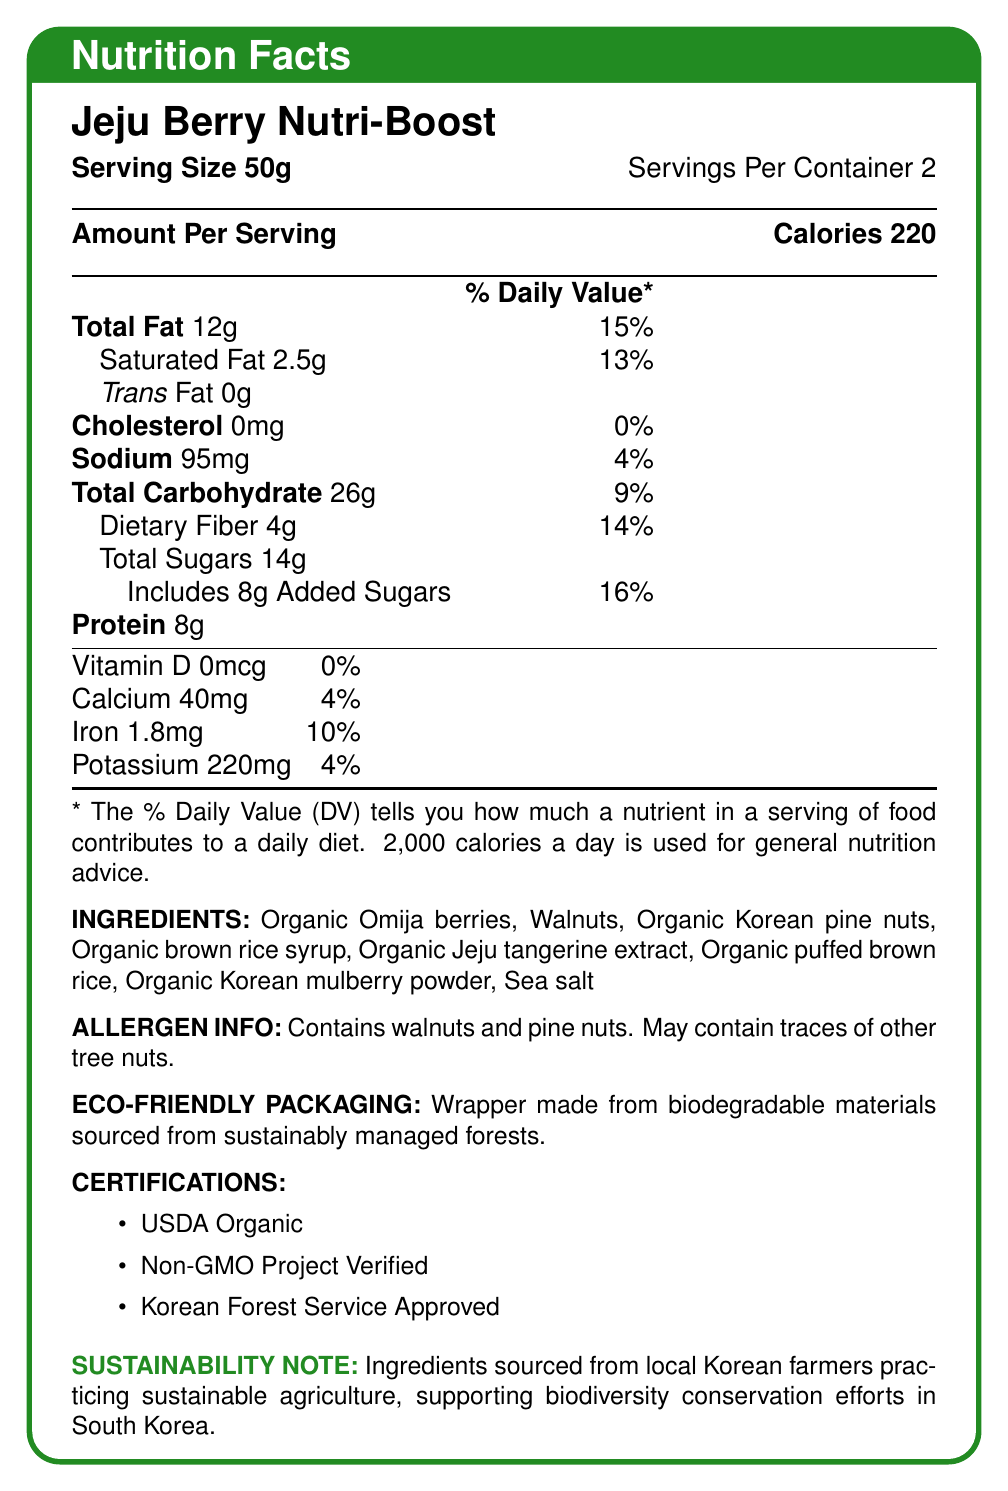what is the serving size? The document states that the serving size is 50g.
Answer: 50g how many servings are there per container? The document shows that there are 2 servings per container.
Answer: 2 how many calories are there per serving? The document states that there are 220 calories per serving.
Answer: 220 what is the total fat content per serving? The total fat content per serving is listed as 12g in the document.
Answer: 12g what percentage of daily value for saturated fat does the bar provide? The document indicates that the bar provides 13% of the daily value for saturated fat per serving.
Answer: 13% what are the main ingredients of the energy bar? These ingredients are listed under the "INGREDIENTS" section of the document.
Answer: Organic Omija berries, Walnuts, Organic Korean pine nuts, Organic brown rice syrup, Organic Jeju tangerine extract, Organic puffed brown rice, Organic Korean mulberry powder, Sea salt what allergens are present in the Jeju Berry Nutri-Boost? A. Pine nuts B. Walnuts C. Cashews D. Peanuts The document states that the product contains walnuts and pine nuts.
Answer: A, B which certifications does this energy bar have? A. USDA Organic B. Fair Trade Certified C. Non-GMO Project Verified D. Korean Forest Service Approved The document lists USDA Organic, Non-GMO Project Verified, and Korean Forest Service Approved as certifications.
Answer: A, C, D is the wrapper of the Jeju Berry Nutri-Boost biodegradable? The document mentions that the wrapper is made from biodegradable materials sourced from sustainably managed forests.
Answer: Yes what is the main idea of the Jeju Berry Nutri-Boost's sustainability note? The sustainability note in the document details that the ingredients are sourced from local Korean farmers practicing sustainable agriculture, contributing to biodiversity conservation efforts in South Korea.
Answer: Ingredients are sourced from local Korean farmers who practice sustainable agriculture, supporting biodiversity conservation efforts in South Korea. how much sodium is in one serving? The document lists 95mg of sodium per serving.
Answer: 95mg what is the amount of dietary fiber per serving and its percentage of the daily value? The dietary fiber per serving is 4g, which is 14% of the daily value as listed in the document.
Answer: 4g, 14% how much protein is in one serving of Jeju Berry Nutri-Boost? The document states that there are 8g of protein in one serving.
Answer: 8g which nutrient has the highest daily value percentage in one serving of Jeju Berry Nutri-Boost? Added sugars have the highest daily value percentage at 16% per serving, as indicated in the document.
Answer: Added sugars what is the daily value percentage of calcium in one serving? The document indicates that the daily value percentage of calcium in one serving is 4%.
Answer: 4% can you determine the exact sugar content of the organic Jeju tangerine extract from the document? The document does not provide specific information on the sugar content of the organic Jeju tangerine extract alone.
Answer: Not enough information 